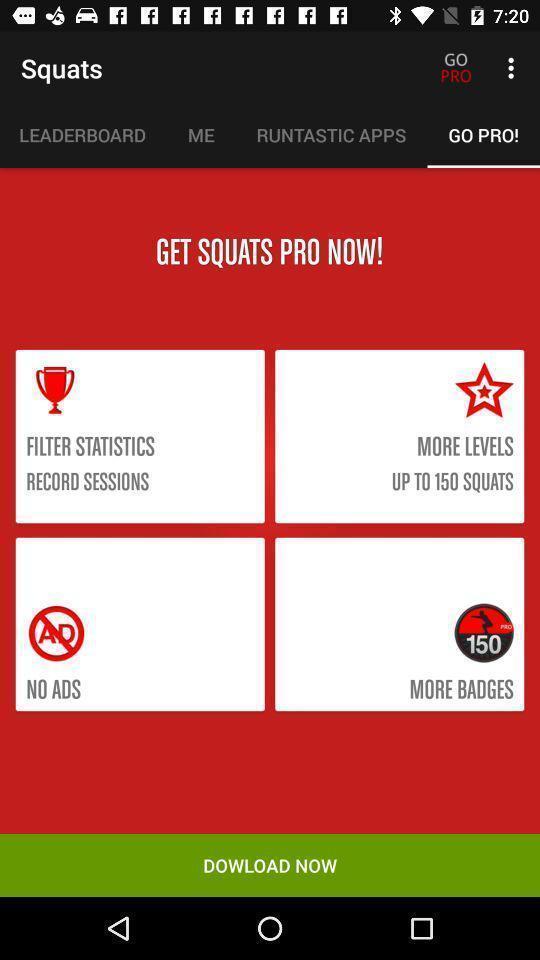Please provide a description for this image. Screen displaying the page of a fitness app. 